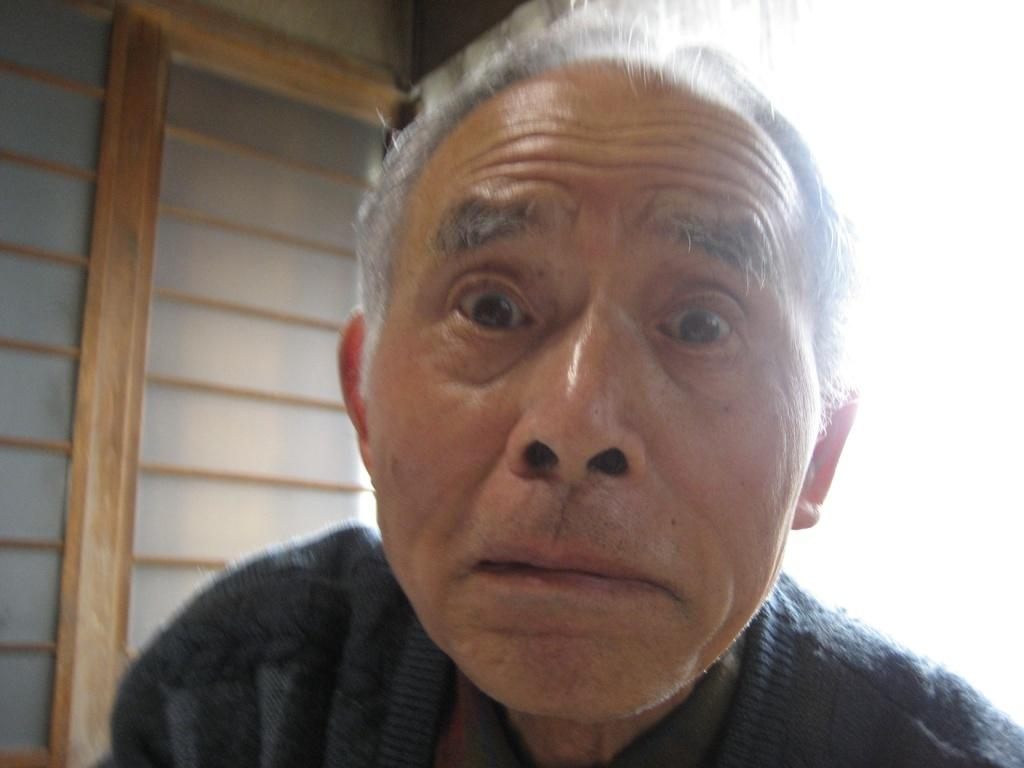What is the main subject of the image? There is a man in the image. Can you describe the color of the image? The image appears to be white. Can you see a toad saying good-bye on the coast in the image? There is no toad or coast present in the image, and no one is saying good-bye. 